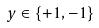<formula> <loc_0><loc_0><loc_500><loc_500>y \in \{ + 1 , - 1 \}</formula> 